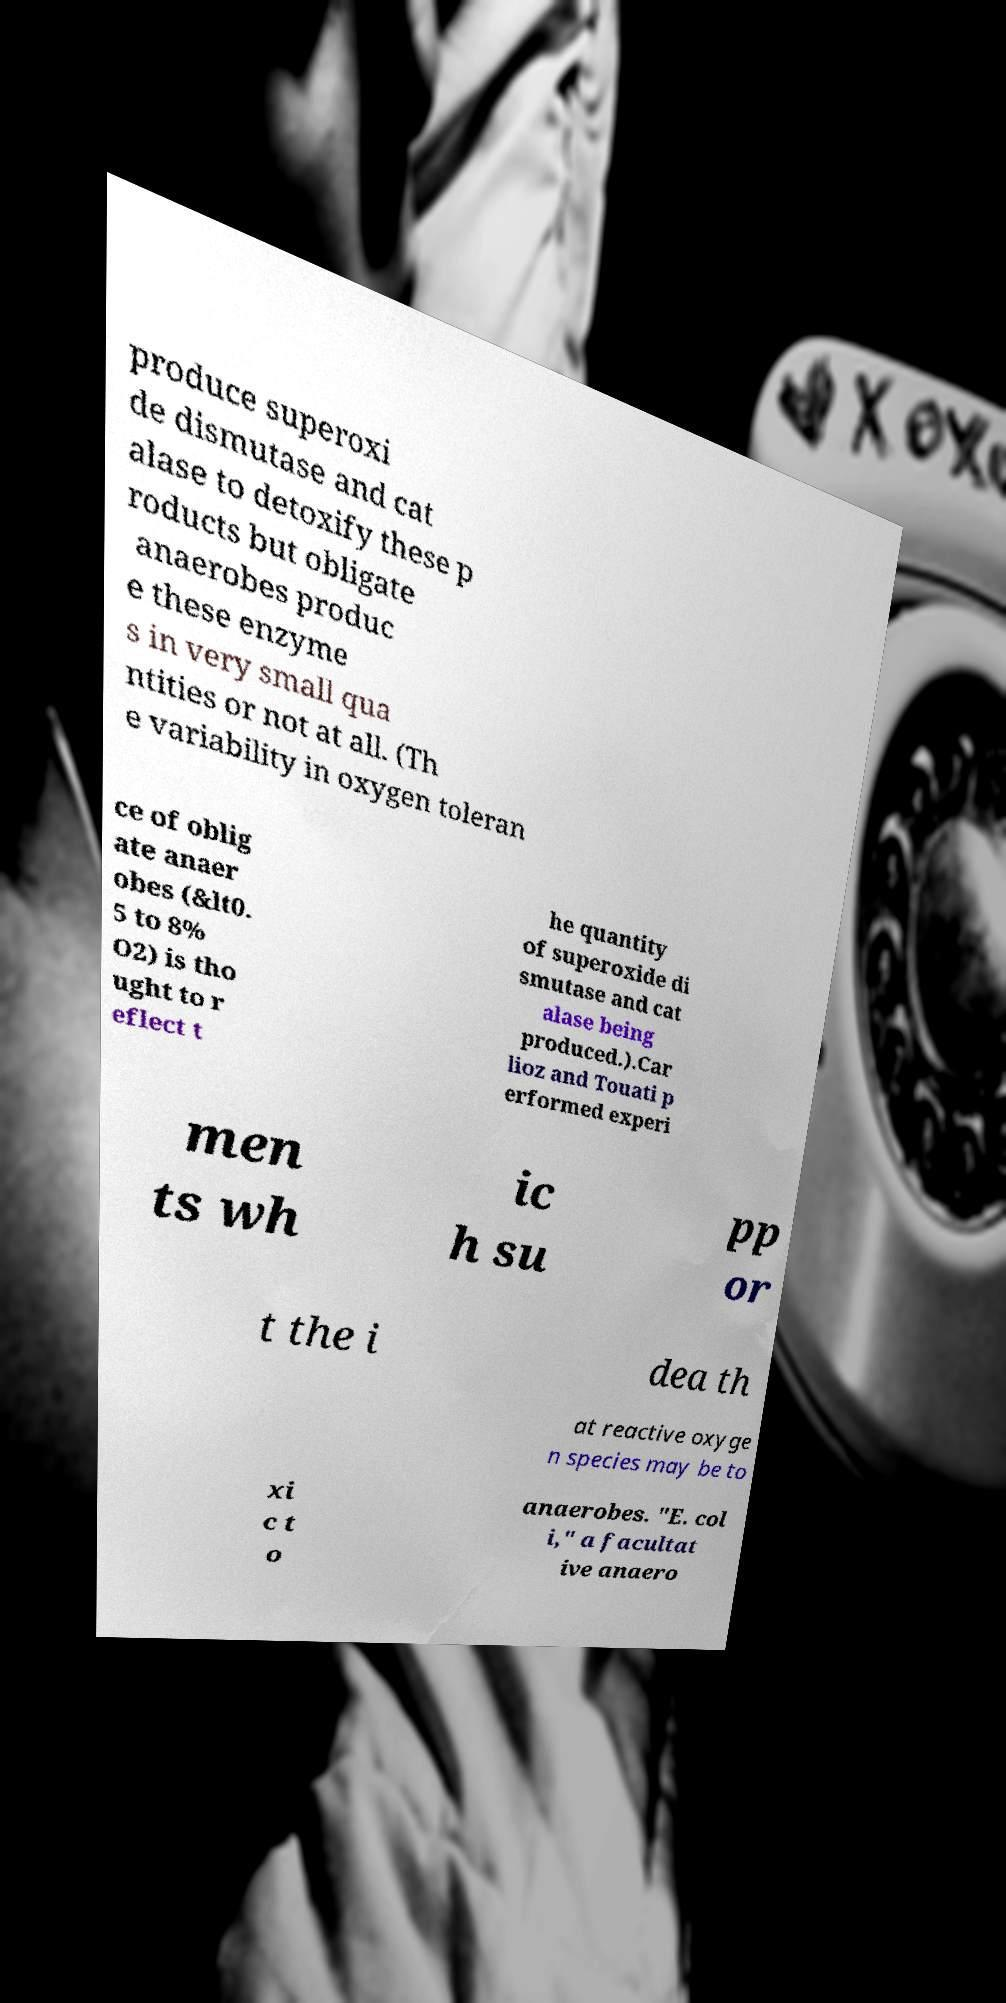Could you extract and type out the text from this image? produce superoxi de dismutase and cat alase to detoxify these p roducts but obligate anaerobes produc e these enzyme s in very small qua ntities or not at all. (Th e variability in oxygen toleran ce of oblig ate anaer obes (&lt0. 5 to 8% O2) is tho ught to r eflect t he quantity of superoxide di smutase and cat alase being produced.).Car lioz and Touati p erformed experi men ts wh ic h su pp or t the i dea th at reactive oxyge n species may be to xi c t o anaerobes. "E. col i," a facultat ive anaero 